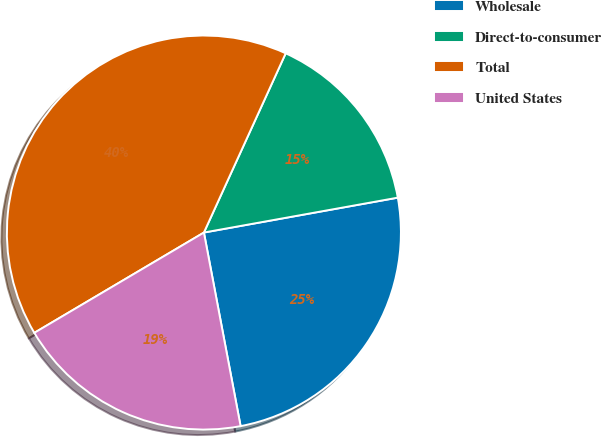<chart> <loc_0><loc_0><loc_500><loc_500><pie_chart><fcel>Wholesale<fcel>Direct-to-consumer<fcel>Total<fcel>United States<nl><fcel>24.85%<fcel>15.35%<fcel>40.31%<fcel>19.48%<nl></chart> 